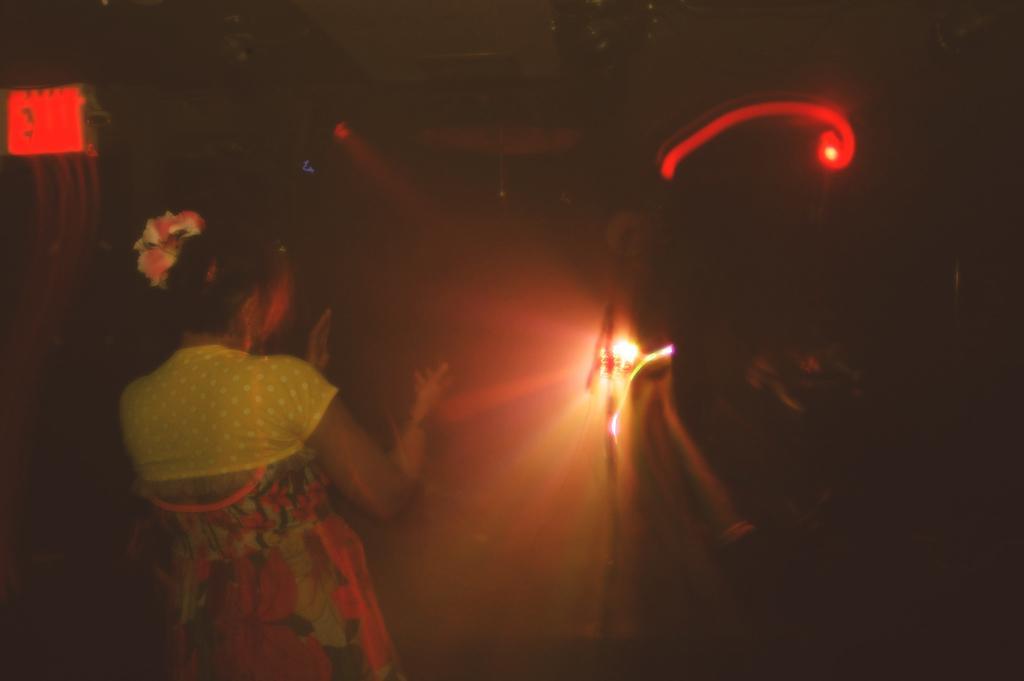Can you describe this image briefly? In this image we can see a dark picture, a woman standing and there are few lights. 